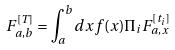Convert formula to latex. <formula><loc_0><loc_0><loc_500><loc_500>F ^ { [ T ] } _ { a , b } = \int _ { a } ^ { b } d x f ( x ) \Pi _ { i } F ^ { [ t _ { i } ] } _ { a , x }</formula> 